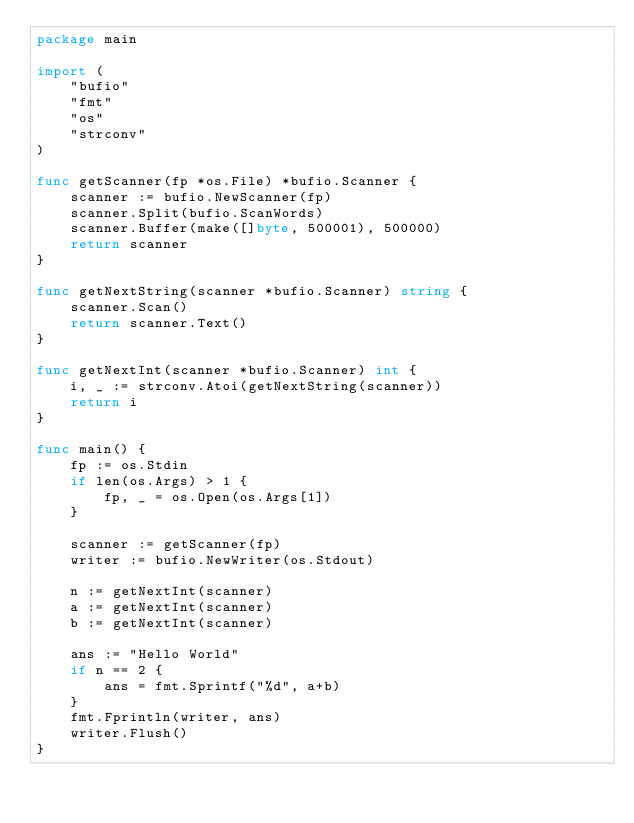Convert code to text. <code><loc_0><loc_0><loc_500><loc_500><_Go_>package main

import (
	"bufio"
	"fmt"
	"os"
	"strconv"
)

func getScanner(fp *os.File) *bufio.Scanner {
	scanner := bufio.NewScanner(fp)
	scanner.Split(bufio.ScanWords)
	scanner.Buffer(make([]byte, 500001), 500000)
	return scanner
}

func getNextString(scanner *bufio.Scanner) string {
	scanner.Scan()
	return scanner.Text()
}

func getNextInt(scanner *bufio.Scanner) int {
	i, _ := strconv.Atoi(getNextString(scanner))
	return i
}

func main() {
	fp := os.Stdin
	if len(os.Args) > 1 {
		fp, _ = os.Open(os.Args[1])
	}

	scanner := getScanner(fp)
	writer := bufio.NewWriter(os.Stdout)

	n := getNextInt(scanner)
	a := getNextInt(scanner)
	b := getNextInt(scanner)

	ans := "Hello World"
	if n == 2 {
		ans = fmt.Sprintf("%d", a+b)
	}
	fmt.Fprintln(writer, ans)
	writer.Flush()
}
</code> 